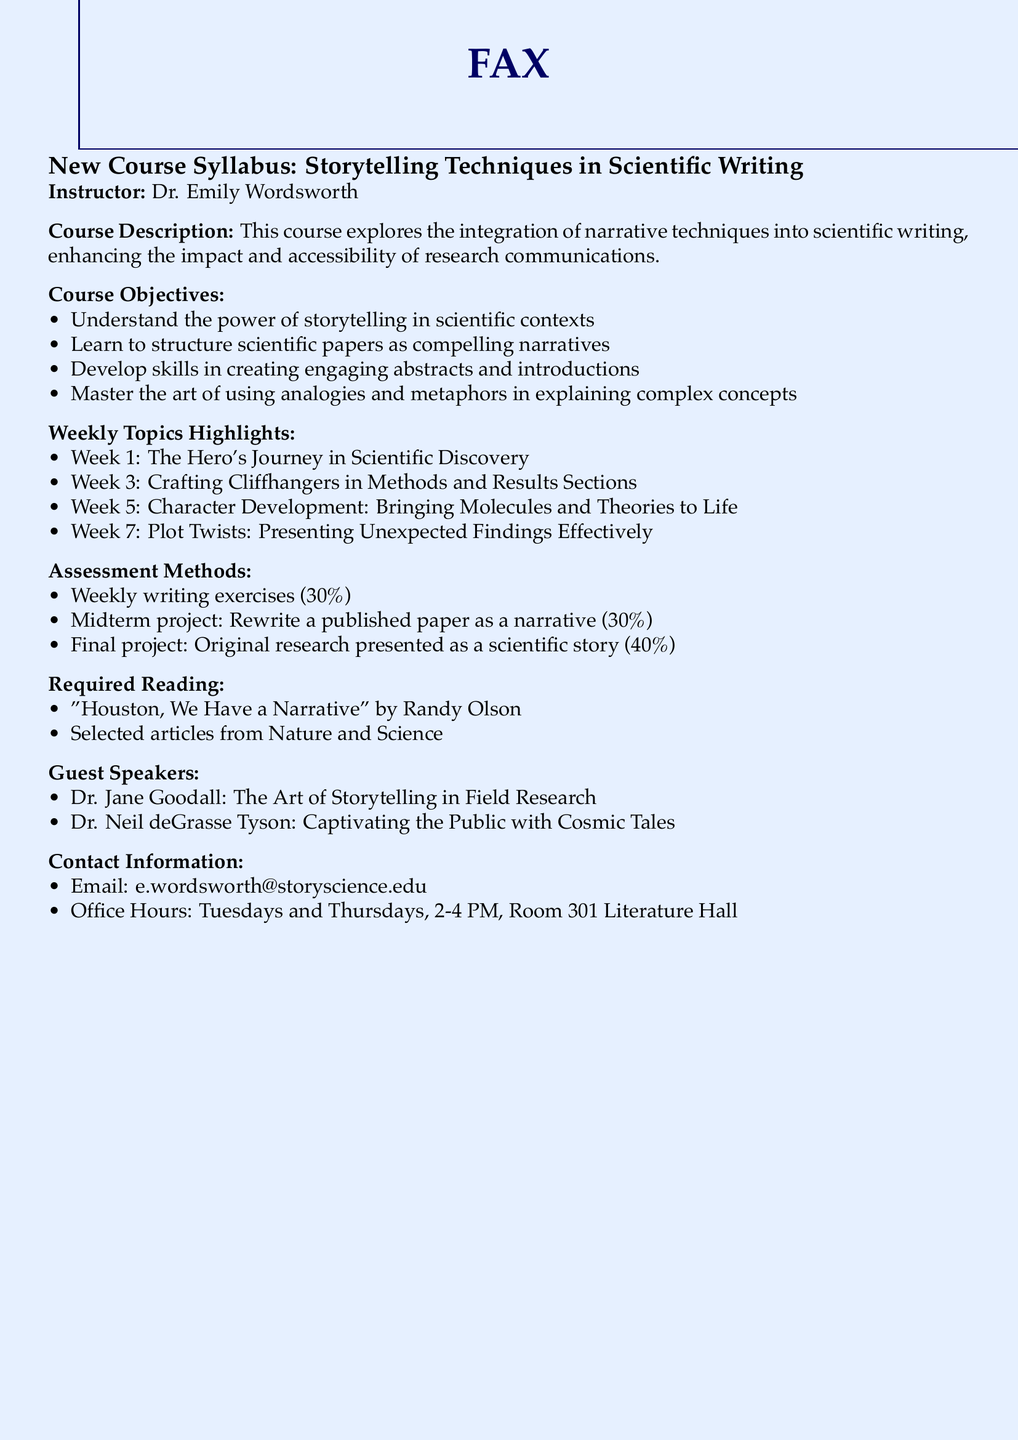What is the name of the instructor? The instructor's name is stated in the document as Dr. Emily Wordsworth.
Answer: Dr. Emily Wordsworth What is the weight of the final project? The document lists the weight of the final project, which accounts for 40% of the total assessment.
Answer: 40% What is the title of the required reading by Randy Olson? The required reading is specified by its title in the document, which is "Houston, We Have a Narrative."
Answer: Houston, We Have a Narrative In which week is "Character Development" discussed? The document specifies that "Character Development: Bringing Molecules and Theories to Life" is discussed in Week 5.
Answer: Week 5 What percentage of the assessment consists of weekly writing exercises? The document indicates that the percentage for weekly writing exercises is 30%.
Answer: 30% Who is one of the guest speakers mentioned in the document? The document lists guest speakers, and one mentioned is Dr. Jane Goodall.
Answer: Dr. Jane Goodall On which days are office hours held? The document describes office hours as occurring on Tuesdays and Thursdays.
Answer: Tuesdays and Thursdays Which room is the instructor's office located in? The document specifies that the instructor's office is located in Room 301 Literature Hall.
Answer: Room 301 Literature Hall What is a key topic discussed in Week 3? The document highlights that the topic for Week 3 is "Crafting Cliffhangers in Methods and Results Sections."
Answer: Crafting Cliffhangers in Methods and Results Sections 